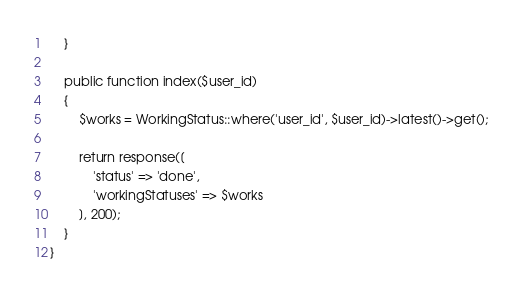Convert code to text. <code><loc_0><loc_0><loc_500><loc_500><_PHP_>    }

    public function index($user_id)
    {
        $works = WorkingStatus::where('user_id', $user_id)->latest()->get();

        return response([
            'status' => 'done',
            'workingStatuses' => $works
        ], 200);
    }
}
</code> 